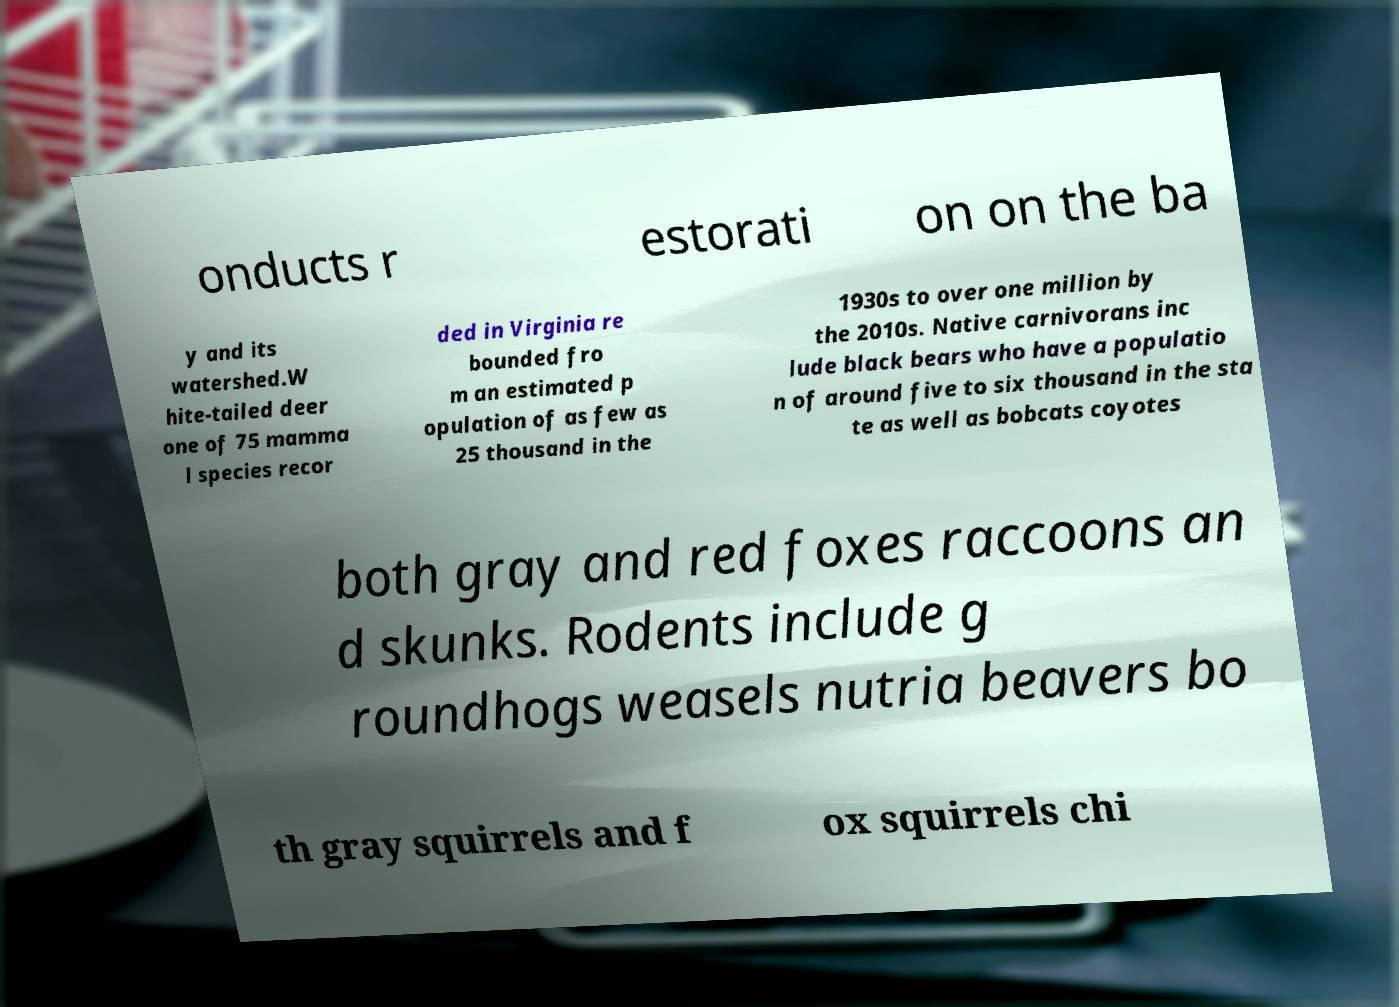Could you assist in decoding the text presented in this image and type it out clearly? onducts r estorati on on the ba y and its watershed.W hite-tailed deer one of 75 mamma l species recor ded in Virginia re bounded fro m an estimated p opulation of as few as 25 thousand in the 1930s to over one million by the 2010s. Native carnivorans inc lude black bears who have a populatio n of around five to six thousand in the sta te as well as bobcats coyotes both gray and red foxes raccoons an d skunks. Rodents include g roundhogs weasels nutria beavers bo th gray squirrels and f ox squirrels chi 